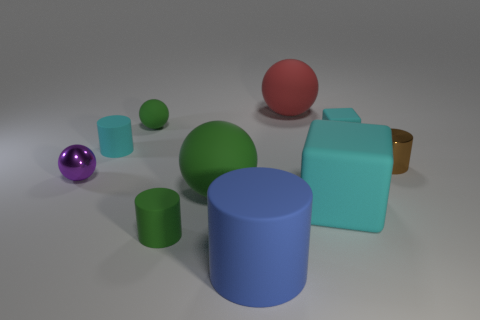Subtract all cyan cylinders. How many cylinders are left? 3 Subtract all brown cylinders. How many cylinders are left? 3 Subtract all gray cylinders. Subtract all brown cubes. How many cylinders are left? 4 Subtract all cyan balls. How many gray cylinders are left? 0 Subtract all yellow metallic cubes. Subtract all tiny brown metallic things. How many objects are left? 9 Add 3 rubber spheres. How many rubber spheres are left? 6 Add 9 yellow metal balls. How many yellow metal balls exist? 9 Subtract 0 yellow cylinders. How many objects are left? 10 Subtract all blocks. How many objects are left? 8 Subtract 2 spheres. How many spheres are left? 2 